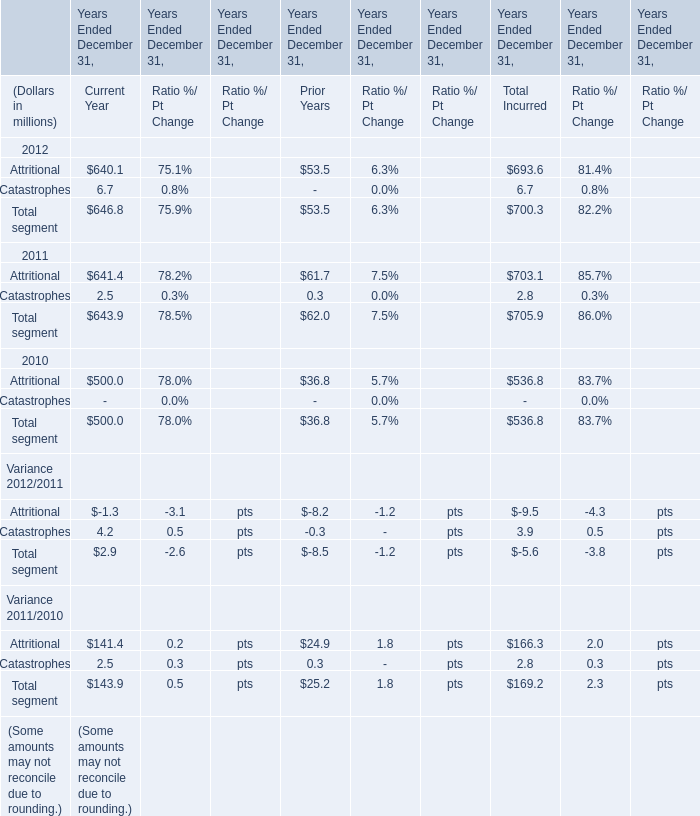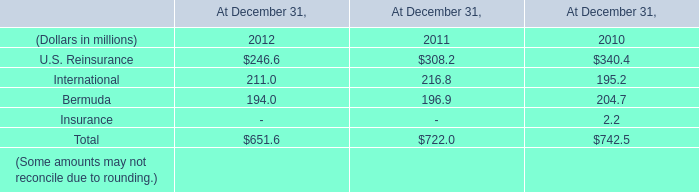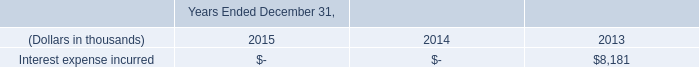what is the total value of notes issues by kilimanjaro in 2014 and 2015? 
Computations: ((450000 + 500000) + 625000)
Answer: 1575000.0. 